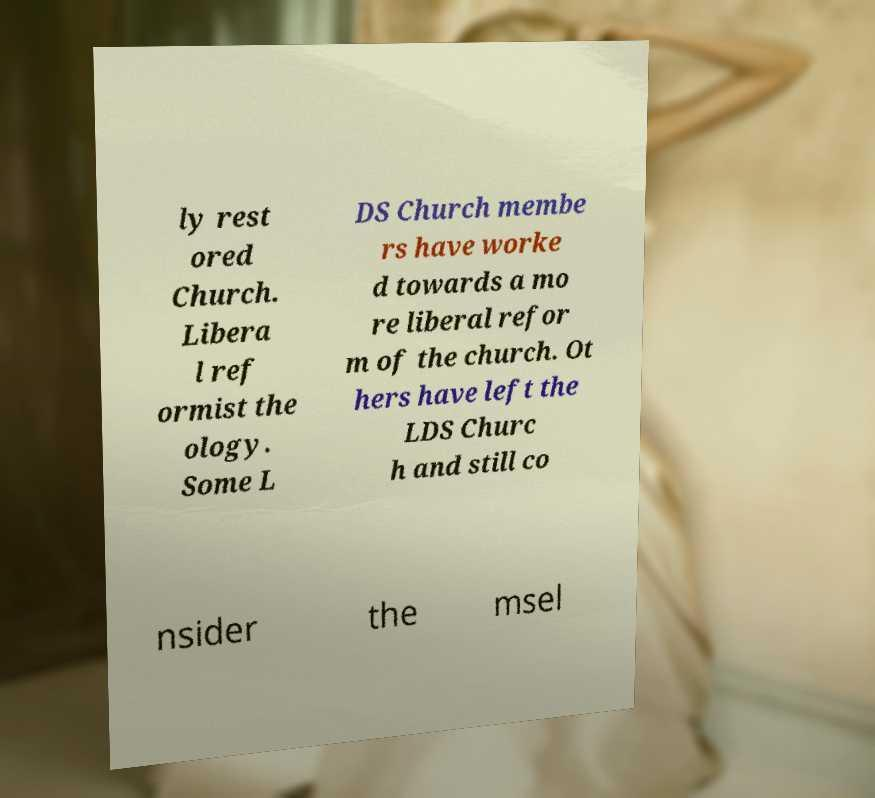Can you accurately transcribe the text from the provided image for me? ly rest ored Church. Libera l ref ormist the ology. Some L DS Church membe rs have worke d towards a mo re liberal refor m of the church. Ot hers have left the LDS Churc h and still co nsider the msel 